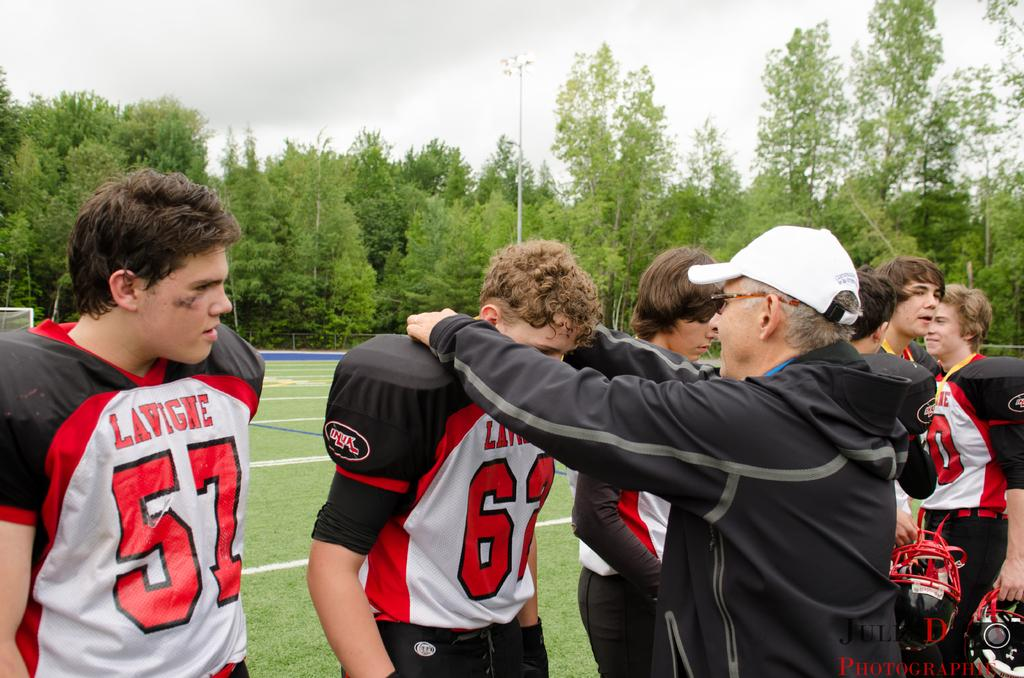Provide a one-sentence caption for the provided image. A young man wearing a white and black jersey that says "Lavigne" stands next to others and an older man in a white hat. 